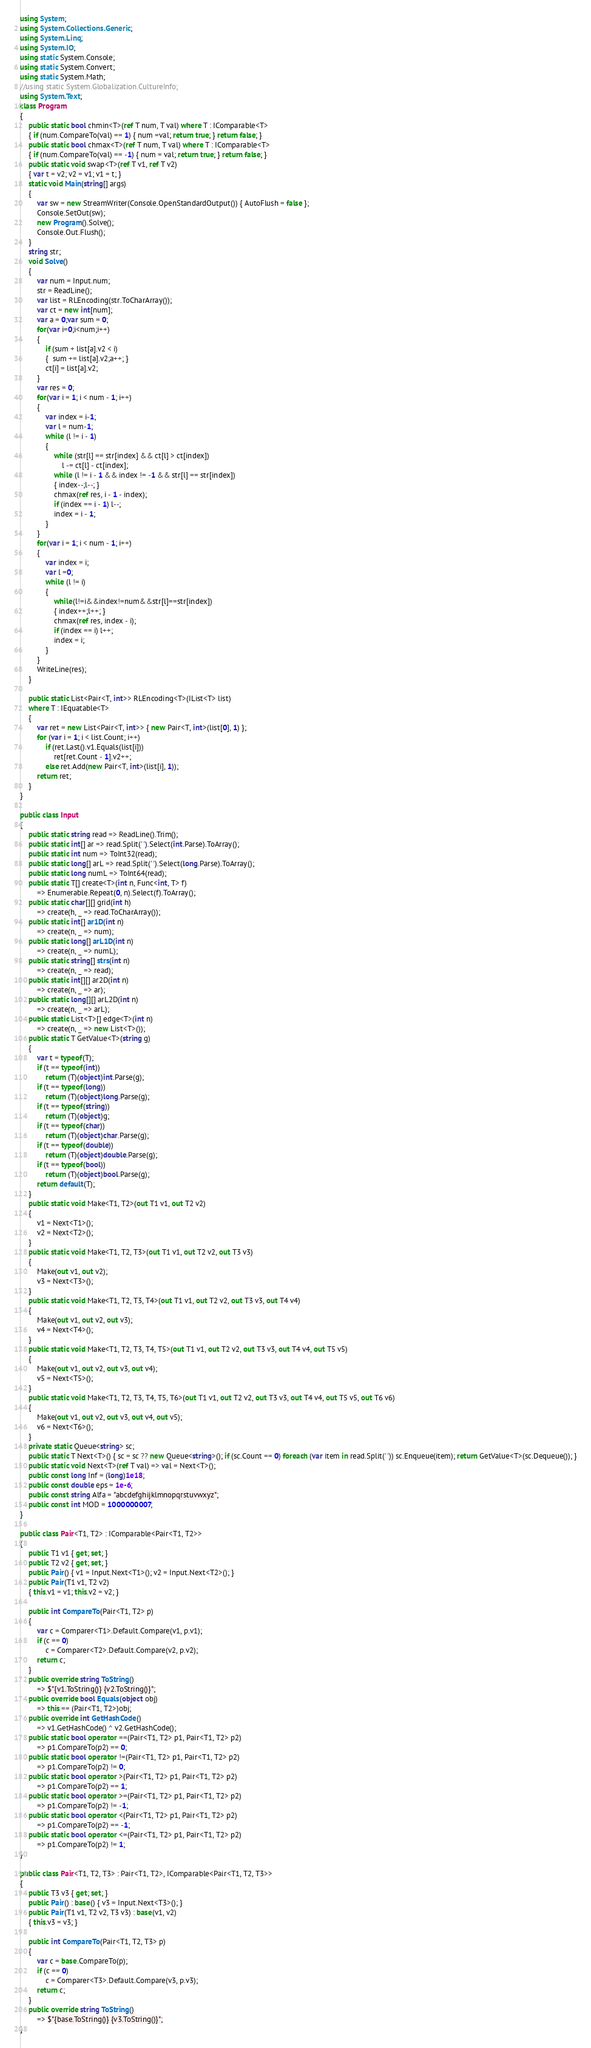Convert code to text. <code><loc_0><loc_0><loc_500><loc_500><_C#_>using System;
using System.Collections.Generic;
using System.Linq;
using System.IO;
using static System.Console;
using static System.Convert;
using static System.Math;
//using static System.Globalization.CultureInfo;
using System.Text;
class Program
{
    public static bool chmin<T>(ref T num, T val) where T : IComparable<T>
    { if (num.CompareTo(val) == 1) { num =val; return true; } return false; }
    public static bool chmax<T>(ref T num, T val) where T : IComparable<T>
    { if (num.CompareTo(val) == -1) { num = val; return true; } return false; }
    public static void swap<T>(ref T v1, ref T v2)
    { var t = v2; v2 = v1; v1 = t; }
    static void Main(string[] args)
    {
        var sw = new StreamWriter(Console.OpenStandardOutput()) { AutoFlush = false };
        Console.SetOut(sw);
        new Program().Solve();
        Console.Out.Flush();
    }
    string str;
    void Solve()
    {
        var num = Input.num;
        str = ReadLine();
        var list = RLEncoding(str.ToCharArray());
        var ct = new int[num];
        var a = 0;var sum = 0;
        for(var i=0;i<num;i++)
        {
            if (sum + list[a].v2 < i)
            {  sum += list[a].v2;a++; }
            ct[i] = list[a].v2;
        }
        var res = 0;
        for(var i = 1; i < num - 1; i++)
        {
            var index = i-1;
            var l = num-1;
            while (l != i - 1)
            {
                while (str[l] == str[index] && ct[l] > ct[index])
                    l -= ct[l] - ct[index];
                while (l != i - 1 && index != -1 && str[l] == str[index])
                { index--;l--; }
                chmax(ref res, i - 1 - index);
                if (index == i - 1) l--;
                index = i - 1;
            }
        }
        for(var i = 1; i < num - 1; i++)
        {
            var index = i;
            var l =0;
            while (l != i)
            {
                while(l!=i&&index!=num&&str[l]==str[index])
                { index++;l++; }
                chmax(ref res, index - i);
                if (index == i) l++;
                index = i;
            }
        }
        WriteLine(res);
    }

    public static List<Pair<T, int>> RLEncoding<T>(IList<T> list)
    where T : IEquatable<T>
    {
        var ret = new List<Pair<T, int>> { new Pair<T, int>(list[0], 1) };
        for (var i = 1; i < list.Count; i++)
            if (ret.Last().v1.Equals(list[i]))
                ret[ret.Count - 1].v2++;
            else ret.Add(new Pair<T, int>(list[i], 1));
        return ret;
    }
}

public class Input
{
    public static string read => ReadLine().Trim();
    public static int[] ar => read.Split(' ').Select(int.Parse).ToArray();
    public static int num => ToInt32(read);
    public static long[] arL => read.Split(' ').Select(long.Parse).ToArray();
    public static long numL => ToInt64(read);
    public static T[] create<T>(int n, Func<int, T> f)
        => Enumerable.Repeat(0, n).Select(f).ToArray();
    public static char[][] grid(int h)
        => create(h, _ => read.ToCharArray());
    public static int[] ar1D(int n)
        => create(n, _ => num);
    public static long[] arL1D(int n)
        => create(n, _ => numL);
    public static string[] strs(int n)
        => create(n, _ => read);
    public static int[][] ar2D(int n)
        => create(n, _ => ar);
    public static long[][] arL2D(int n)
        => create(n, _ => arL);
    public static List<T>[] edge<T>(int n)
        => create(n, _ => new List<T>());
    public static T GetValue<T>(string g)
    {
        var t = typeof(T);
        if (t == typeof(int))
            return (T)(object)int.Parse(g);
        if (t == typeof(long))
            return (T)(object)long.Parse(g);
        if (t == typeof(string))
            return (T)(object)g;
        if (t == typeof(char))
            return (T)(object)char.Parse(g);
        if (t == typeof(double))
            return (T)(object)double.Parse(g);
        if (t == typeof(bool))
            return (T)(object)bool.Parse(g);
        return default(T);
    }
    public static void Make<T1, T2>(out T1 v1, out T2 v2)
    {
        v1 = Next<T1>();
        v2 = Next<T2>();
    }
    public static void Make<T1, T2, T3>(out T1 v1, out T2 v2, out T3 v3)
    {
        Make(out v1, out v2);
        v3 = Next<T3>();
    }
    public static void Make<T1, T2, T3, T4>(out T1 v1, out T2 v2, out T3 v3, out T4 v4)
    {
        Make(out v1, out v2, out v3);
        v4 = Next<T4>();
    }
    public static void Make<T1, T2, T3, T4, T5>(out T1 v1, out T2 v2, out T3 v3, out T4 v4, out T5 v5)
    {
        Make(out v1, out v2, out v3, out v4);
        v5 = Next<T5>();
    }
    public static void Make<T1, T2, T3, T4, T5, T6>(out T1 v1, out T2 v2, out T3 v3, out T4 v4, out T5 v5, out T6 v6)
    {
        Make(out v1, out v2, out v3, out v4, out v5);
        v6 = Next<T6>();
    }
    private static Queue<string> sc;
    public static T Next<T>() { sc = sc ?? new Queue<string>(); if (sc.Count == 0) foreach (var item in read.Split(' ')) sc.Enqueue(item); return GetValue<T>(sc.Dequeue()); }
    public static void Next<T>(ref T val) => val = Next<T>();
    public const long Inf = (long)1e18;
    public const double eps = 1e-6;
    public const string Alfa = "abcdefghijklmnopqrstuvwxyz";
    public const int MOD = 1000000007;
}

public class Pair<T1, T2> : IComparable<Pair<T1, T2>>
{
    public T1 v1 { get; set; }
    public T2 v2 { get; set; }
    public Pair() { v1 = Input.Next<T1>(); v2 = Input.Next<T2>(); }
    public Pair(T1 v1, T2 v2)
    { this.v1 = v1; this.v2 = v2; }

    public int CompareTo(Pair<T1, T2> p)
    {
        var c = Comparer<T1>.Default.Compare(v1, p.v1);
        if (c == 0)
            c = Comparer<T2>.Default.Compare(v2, p.v2);
        return c;
    }
    public override string ToString()
        => $"{v1.ToString()} {v2.ToString()}";
    public override bool Equals(object obj)
        => this == (Pair<T1, T2>)obj;
    public override int GetHashCode()
        => v1.GetHashCode() ^ v2.GetHashCode();
    public static bool operator ==(Pair<T1, T2> p1, Pair<T1, T2> p2)
        => p1.CompareTo(p2) == 0;
    public static bool operator !=(Pair<T1, T2> p1, Pair<T1, T2> p2)
        => p1.CompareTo(p2) != 0;
    public static bool operator >(Pair<T1, T2> p1, Pair<T1, T2> p2)
        => p1.CompareTo(p2) == 1;
    public static bool operator >=(Pair<T1, T2> p1, Pair<T1, T2> p2)
        => p1.CompareTo(p2) != -1;
    public static bool operator <(Pair<T1, T2> p1, Pair<T1, T2> p2)
        => p1.CompareTo(p2) == -1;
    public static bool operator <=(Pair<T1, T2> p1, Pair<T1, T2> p2)
        => p1.CompareTo(p2) != 1;
}

public class Pair<T1, T2, T3> : Pair<T1, T2>, IComparable<Pair<T1, T2, T3>>
{
    public T3 v3 { get; set; }
    public Pair() : base() { v3 = Input.Next<T3>(); }
    public Pair(T1 v1, T2 v2, T3 v3) : base(v1, v2)
    { this.v3 = v3; }

    public int CompareTo(Pair<T1, T2, T3> p)
    {
        var c = base.CompareTo(p);
        if (c == 0)
            c = Comparer<T3>.Default.Compare(v3, p.v3);
        return c;
    }
    public override string ToString()
        => $"{base.ToString()} {v3.ToString()}";
}

</code> 